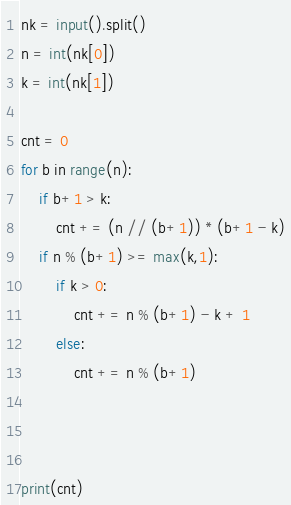Convert code to text. <code><loc_0><loc_0><loc_500><loc_500><_Python_>nk = input().split()
n = int(nk[0])
k = int(nk[1])

cnt = 0
for b in range(n):
    if b+1 > k:
        cnt += (n // (b+1)) * (b+1 - k)
    if n % (b+1) >= max(k,1):
        if k > 0:
            cnt += n % (b+1) - k + 1
        else:
            cnt += n % (b+1)

        

print(cnt)</code> 